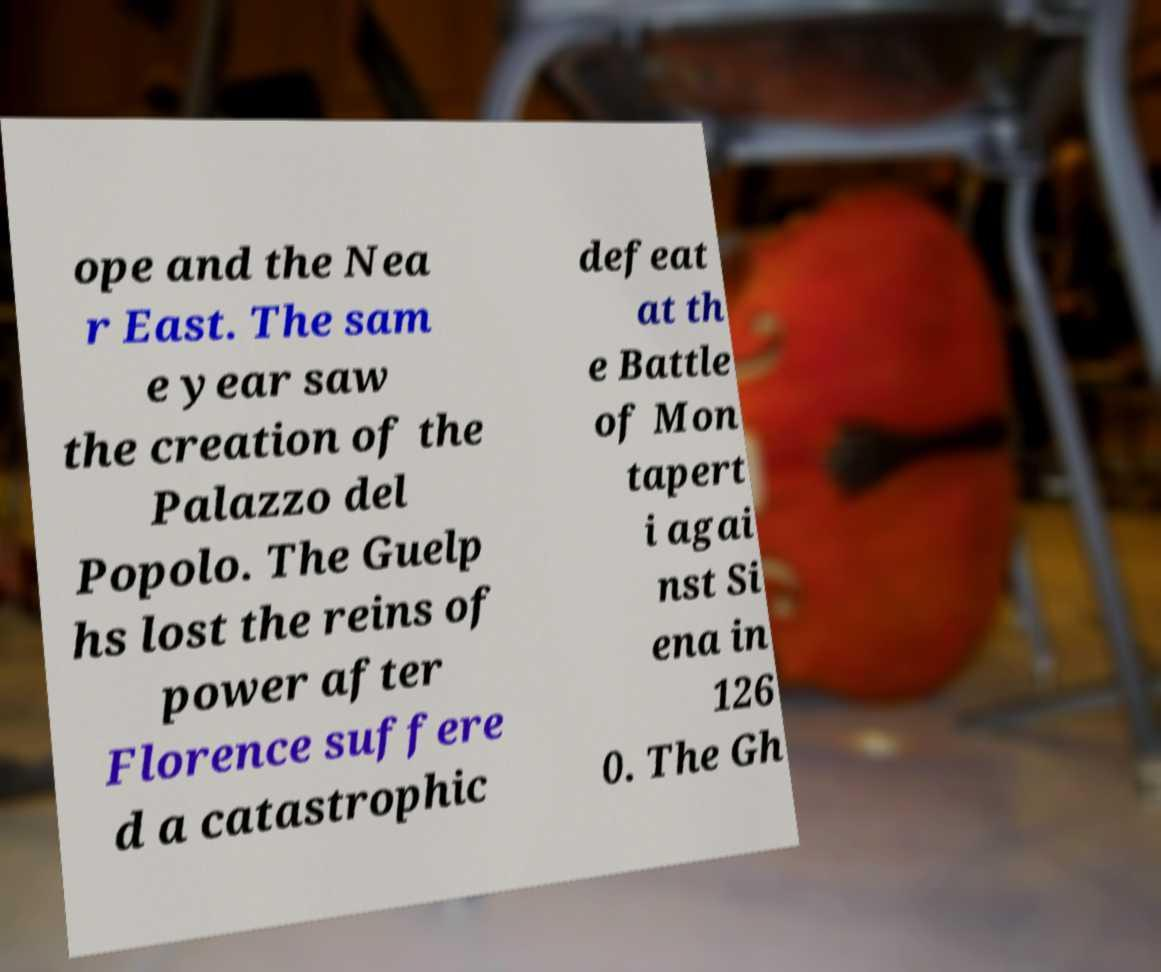There's text embedded in this image that I need extracted. Can you transcribe it verbatim? ope and the Nea r East. The sam e year saw the creation of the Palazzo del Popolo. The Guelp hs lost the reins of power after Florence suffere d a catastrophic defeat at th e Battle of Mon tapert i agai nst Si ena in 126 0. The Gh 